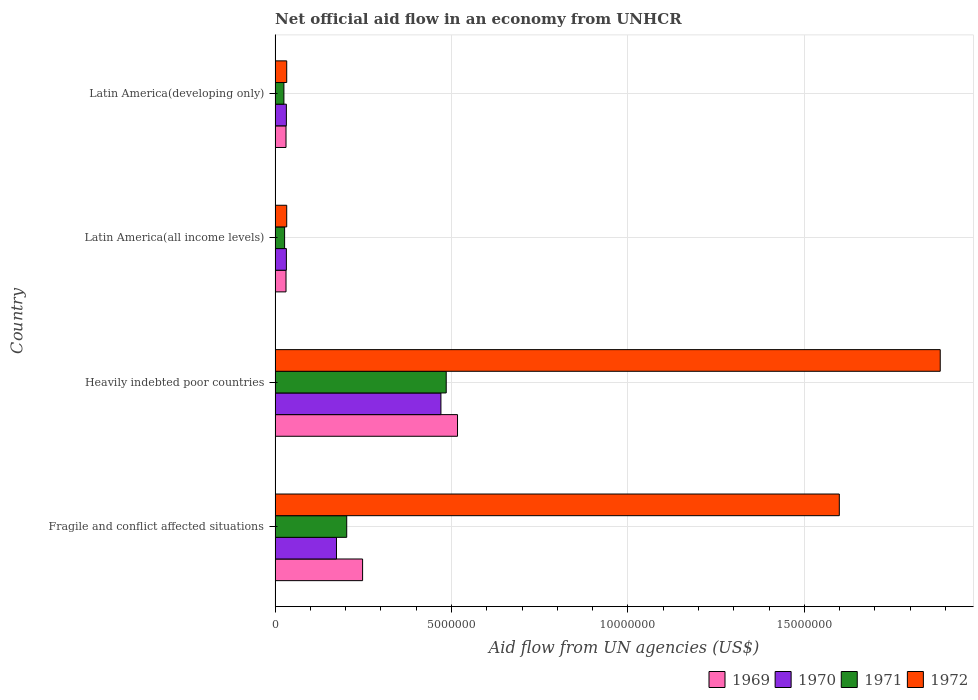How many groups of bars are there?
Your answer should be compact. 4. Are the number of bars per tick equal to the number of legend labels?
Ensure brevity in your answer.  Yes. Are the number of bars on each tick of the Y-axis equal?
Make the answer very short. Yes. How many bars are there on the 3rd tick from the top?
Ensure brevity in your answer.  4. How many bars are there on the 3rd tick from the bottom?
Give a very brief answer. 4. What is the label of the 1st group of bars from the top?
Your answer should be compact. Latin America(developing only). In how many cases, is the number of bars for a given country not equal to the number of legend labels?
Offer a terse response. 0. What is the net official aid flow in 1972 in Latin America(developing only)?
Give a very brief answer. 3.30e+05. Across all countries, what is the maximum net official aid flow in 1969?
Offer a terse response. 5.17e+06. Across all countries, what is the minimum net official aid flow in 1969?
Give a very brief answer. 3.10e+05. In which country was the net official aid flow in 1970 maximum?
Your response must be concise. Heavily indebted poor countries. In which country was the net official aid flow in 1969 minimum?
Ensure brevity in your answer.  Latin America(all income levels). What is the total net official aid flow in 1972 in the graph?
Your answer should be compact. 3.55e+07. What is the difference between the net official aid flow in 1969 in Heavily indebted poor countries and that in Latin America(developing only)?
Ensure brevity in your answer.  4.86e+06. What is the difference between the net official aid flow in 1971 in Heavily indebted poor countries and the net official aid flow in 1970 in Fragile and conflict affected situations?
Give a very brief answer. 3.11e+06. What is the average net official aid flow in 1970 per country?
Keep it short and to the point. 1.77e+06. In how many countries, is the net official aid flow in 1970 greater than 17000000 US$?
Provide a succinct answer. 0. What is the ratio of the net official aid flow in 1971 in Fragile and conflict affected situations to that in Latin America(developing only)?
Provide a succinct answer. 8.12. What is the difference between the highest and the second highest net official aid flow in 1969?
Your answer should be compact. 2.69e+06. What is the difference between the highest and the lowest net official aid flow in 1972?
Make the answer very short. 1.85e+07. What does the 1st bar from the bottom in Fragile and conflict affected situations represents?
Make the answer very short. 1969. How many countries are there in the graph?
Your response must be concise. 4. Does the graph contain any zero values?
Provide a short and direct response. No. Does the graph contain grids?
Provide a short and direct response. Yes. Where does the legend appear in the graph?
Your answer should be compact. Bottom right. What is the title of the graph?
Your response must be concise. Net official aid flow in an economy from UNHCR. Does "2005" appear as one of the legend labels in the graph?
Your response must be concise. No. What is the label or title of the X-axis?
Ensure brevity in your answer.  Aid flow from UN agencies (US$). What is the Aid flow from UN agencies (US$) in 1969 in Fragile and conflict affected situations?
Your response must be concise. 2.48e+06. What is the Aid flow from UN agencies (US$) of 1970 in Fragile and conflict affected situations?
Ensure brevity in your answer.  1.74e+06. What is the Aid flow from UN agencies (US$) in 1971 in Fragile and conflict affected situations?
Your response must be concise. 2.03e+06. What is the Aid flow from UN agencies (US$) of 1972 in Fragile and conflict affected situations?
Your response must be concise. 1.60e+07. What is the Aid flow from UN agencies (US$) in 1969 in Heavily indebted poor countries?
Your answer should be compact. 5.17e+06. What is the Aid flow from UN agencies (US$) in 1970 in Heavily indebted poor countries?
Provide a short and direct response. 4.70e+06. What is the Aid flow from UN agencies (US$) in 1971 in Heavily indebted poor countries?
Offer a terse response. 4.85e+06. What is the Aid flow from UN agencies (US$) of 1972 in Heavily indebted poor countries?
Offer a terse response. 1.88e+07. What is the Aid flow from UN agencies (US$) of 1969 in Latin America(all income levels)?
Your response must be concise. 3.10e+05. What is the Aid flow from UN agencies (US$) of 1971 in Latin America(all income levels)?
Your answer should be very brief. 2.70e+05. What is the Aid flow from UN agencies (US$) in 1971 in Latin America(developing only)?
Give a very brief answer. 2.50e+05. Across all countries, what is the maximum Aid flow from UN agencies (US$) in 1969?
Offer a very short reply. 5.17e+06. Across all countries, what is the maximum Aid flow from UN agencies (US$) in 1970?
Your response must be concise. 4.70e+06. Across all countries, what is the maximum Aid flow from UN agencies (US$) in 1971?
Offer a very short reply. 4.85e+06. Across all countries, what is the maximum Aid flow from UN agencies (US$) of 1972?
Keep it short and to the point. 1.88e+07. Across all countries, what is the minimum Aid flow from UN agencies (US$) of 1971?
Give a very brief answer. 2.50e+05. Across all countries, what is the minimum Aid flow from UN agencies (US$) in 1972?
Offer a very short reply. 3.30e+05. What is the total Aid flow from UN agencies (US$) of 1969 in the graph?
Offer a terse response. 8.27e+06. What is the total Aid flow from UN agencies (US$) in 1970 in the graph?
Give a very brief answer. 7.08e+06. What is the total Aid flow from UN agencies (US$) in 1971 in the graph?
Give a very brief answer. 7.40e+06. What is the total Aid flow from UN agencies (US$) of 1972 in the graph?
Your answer should be very brief. 3.55e+07. What is the difference between the Aid flow from UN agencies (US$) in 1969 in Fragile and conflict affected situations and that in Heavily indebted poor countries?
Your response must be concise. -2.69e+06. What is the difference between the Aid flow from UN agencies (US$) of 1970 in Fragile and conflict affected situations and that in Heavily indebted poor countries?
Keep it short and to the point. -2.96e+06. What is the difference between the Aid flow from UN agencies (US$) of 1971 in Fragile and conflict affected situations and that in Heavily indebted poor countries?
Your answer should be very brief. -2.82e+06. What is the difference between the Aid flow from UN agencies (US$) in 1972 in Fragile and conflict affected situations and that in Heavily indebted poor countries?
Offer a very short reply. -2.86e+06. What is the difference between the Aid flow from UN agencies (US$) in 1969 in Fragile and conflict affected situations and that in Latin America(all income levels)?
Offer a very short reply. 2.17e+06. What is the difference between the Aid flow from UN agencies (US$) in 1970 in Fragile and conflict affected situations and that in Latin America(all income levels)?
Ensure brevity in your answer.  1.42e+06. What is the difference between the Aid flow from UN agencies (US$) of 1971 in Fragile and conflict affected situations and that in Latin America(all income levels)?
Provide a succinct answer. 1.76e+06. What is the difference between the Aid flow from UN agencies (US$) in 1972 in Fragile and conflict affected situations and that in Latin America(all income levels)?
Offer a terse response. 1.57e+07. What is the difference between the Aid flow from UN agencies (US$) in 1969 in Fragile and conflict affected situations and that in Latin America(developing only)?
Offer a terse response. 2.17e+06. What is the difference between the Aid flow from UN agencies (US$) of 1970 in Fragile and conflict affected situations and that in Latin America(developing only)?
Your answer should be very brief. 1.42e+06. What is the difference between the Aid flow from UN agencies (US$) of 1971 in Fragile and conflict affected situations and that in Latin America(developing only)?
Your answer should be very brief. 1.78e+06. What is the difference between the Aid flow from UN agencies (US$) of 1972 in Fragile and conflict affected situations and that in Latin America(developing only)?
Your answer should be very brief. 1.57e+07. What is the difference between the Aid flow from UN agencies (US$) of 1969 in Heavily indebted poor countries and that in Latin America(all income levels)?
Give a very brief answer. 4.86e+06. What is the difference between the Aid flow from UN agencies (US$) in 1970 in Heavily indebted poor countries and that in Latin America(all income levels)?
Offer a very short reply. 4.38e+06. What is the difference between the Aid flow from UN agencies (US$) in 1971 in Heavily indebted poor countries and that in Latin America(all income levels)?
Offer a very short reply. 4.58e+06. What is the difference between the Aid flow from UN agencies (US$) in 1972 in Heavily indebted poor countries and that in Latin America(all income levels)?
Your answer should be compact. 1.85e+07. What is the difference between the Aid flow from UN agencies (US$) in 1969 in Heavily indebted poor countries and that in Latin America(developing only)?
Offer a very short reply. 4.86e+06. What is the difference between the Aid flow from UN agencies (US$) of 1970 in Heavily indebted poor countries and that in Latin America(developing only)?
Offer a very short reply. 4.38e+06. What is the difference between the Aid flow from UN agencies (US$) of 1971 in Heavily indebted poor countries and that in Latin America(developing only)?
Provide a succinct answer. 4.60e+06. What is the difference between the Aid flow from UN agencies (US$) of 1972 in Heavily indebted poor countries and that in Latin America(developing only)?
Your answer should be very brief. 1.85e+07. What is the difference between the Aid flow from UN agencies (US$) in 1969 in Latin America(all income levels) and that in Latin America(developing only)?
Your answer should be very brief. 0. What is the difference between the Aid flow from UN agencies (US$) in 1970 in Latin America(all income levels) and that in Latin America(developing only)?
Keep it short and to the point. 0. What is the difference between the Aid flow from UN agencies (US$) of 1972 in Latin America(all income levels) and that in Latin America(developing only)?
Keep it short and to the point. 0. What is the difference between the Aid flow from UN agencies (US$) of 1969 in Fragile and conflict affected situations and the Aid flow from UN agencies (US$) of 1970 in Heavily indebted poor countries?
Provide a short and direct response. -2.22e+06. What is the difference between the Aid flow from UN agencies (US$) of 1969 in Fragile and conflict affected situations and the Aid flow from UN agencies (US$) of 1971 in Heavily indebted poor countries?
Keep it short and to the point. -2.37e+06. What is the difference between the Aid flow from UN agencies (US$) of 1969 in Fragile and conflict affected situations and the Aid flow from UN agencies (US$) of 1972 in Heavily indebted poor countries?
Keep it short and to the point. -1.64e+07. What is the difference between the Aid flow from UN agencies (US$) in 1970 in Fragile and conflict affected situations and the Aid flow from UN agencies (US$) in 1971 in Heavily indebted poor countries?
Offer a very short reply. -3.11e+06. What is the difference between the Aid flow from UN agencies (US$) in 1970 in Fragile and conflict affected situations and the Aid flow from UN agencies (US$) in 1972 in Heavily indebted poor countries?
Keep it short and to the point. -1.71e+07. What is the difference between the Aid flow from UN agencies (US$) in 1971 in Fragile and conflict affected situations and the Aid flow from UN agencies (US$) in 1972 in Heavily indebted poor countries?
Keep it short and to the point. -1.68e+07. What is the difference between the Aid flow from UN agencies (US$) of 1969 in Fragile and conflict affected situations and the Aid flow from UN agencies (US$) of 1970 in Latin America(all income levels)?
Ensure brevity in your answer.  2.16e+06. What is the difference between the Aid flow from UN agencies (US$) in 1969 in Fragile and conflict affected situations and the Aid flow from UN agencies (US$) in 1971 in Latin America(all income levels)?
Your response must be concise. 2.21e+06. What is the difference between the Aid flow from UN agencies (US$) in 1969 in Fragile and conflict affected situations and the Aid flow from UN agencies (US$) in 1972 in Latin America(all income levels)?
Offer a terse response. 2.15e+06. What is the difference between the Aid flow from UN agencies (US$) of 1970 in Fragile and conflict affected situations and the Aid flow from UN agencies (US$) of 1971 in Latin America(all income levels)?
Your answer should be compact. 1.47e+06. What is the difference between the Aid flow from UN agencies (US$) in 1970 in Fragile and conflict affected situations and the Aid flow from UN agencies (US$) in 1972 in Latin America(all income levels)?
Give a very brief answer. 1.41e+06. What is the difference between the Aid flow from UN agencies (US$) of 1971 in Fragile and conflict affected situations and the Aid flow from UN agencies (US$) of 1972 in Latin America(all income levels)?
Your response must be concise. 1.70e+06. What is the difference between the Aid flow from UN agencies (US$) of 1969 in Fragile and conflict affected situations and the Aid flow from UN agencies (US$) of 1970 in Latin America(developing only)?
Offer a very short reply. 2.16e+06. What is the difference between the Aid flow from UN agencies (US$) of 1969 in Fragile and conflict affected situations and the Aid flow from UN agencies (US$) of 1971 in Latin America(developing only)?
Offer a very short reply. 2.23e+06. What is the difference between the Aid flow from UN agencies (US$) of 1969 in Fragile and conflict affected situations and the Aid flow from UN agencies (US$) of 1972 in Latin America(developing only)?
Provide a short and direct response. 2.15e+06. What is the difference between the Aid flow from UN agencies (US$) of 1970 in Fragile and conflict affected situations and the Aid flow from UN agencies (US$) of 1971 in Latin America(developing only)?
Your answer should be very brief. 1.49e+06. What is the difference between the Aid flow from UN agencies (US$) of 1970 in Fragile and conflict affected situations and the Aid flow from UN agencies (US$) of 1972 in Latin America(developing only)?
Make the answer very short. 1.41e+06. What is the difference between the Aid flow from UN agencies (US$) of 1971 in Fragile and conflict affected situations and the Aid flow from UN agencies (US$) of 1972 in Latin America(developing only)?
Your answer should be very brief. 1.70e+06. What is the difference between the Aid flow from UN agencies (US$) of 1969 in Heavily indebted poor countries and the Aid flow from UN agencies (US$) of 1970 in Latin America(all income levels)?
Offer a terse response. 4.85e+06. What is the difference between the Aid flow from UN agencies (US$) of 1969 in Heavily indebted poor countries and the Aid flow from UN agencies (US$) of 1971 in Latin America(all income levels)?
Provide a succinct answer. 4.90e+06. What is the difference between the Aid flow from UN agencies (US$) in 1969 in Heavily indebted poor countries and the Aid flow from UN agencies (US$) in 1972 in Latin America(all income levels)?
Provide a short and direct response. 4.84e+06. What is the difference between the Aid flow from UN agencies (US$) in 1970 in Heavily indebted poor countries and the Aid flow from UN agencies (US$) in 1971 in Latin America(all income levels)?
Your answer should be compact. 4.43e+06. What is the difference between the Aid flow from UN agencies (US$) in 1970 in Heavily indebted poor countries and the Aid flow from UN agencies (US$) in 1972 in Latin America(all income levels)?
Provide a succinct answer. 4.37e+06. What is the difference between the Aid flow from UN agencies (US$) in 1971 in Heavily indebted poor countries and the Aid flow from UN agencies (US$) in 1972 in Latin America(all income levels)?
Provide a succinct answer. 4.52e+06. What is the difference between the Aid flow from UN agencies (US$) of 1969 in Heavily indebted poor countries and the Aid flow from UN agencies (US$) of 1970 in Latin America(developing only)?
Your response must be concise. 4.85e+06. What is the difference between the Aid flow from UN agencies (US$) of 1969 in Heavily indebted poor countries and the Aid flow from UN agencies (US$) of 1971 in Latin America(developing only)?
Provide a short and direct response. 4.92e+06. What is the difference between the Aid flow from UN agencies (US$) in 1969 in Heavily indebted poor countries and the Aid flow from UN agencies (US$) in 1972 in Latin America(developing only)?
Provide a succinct answer. 4.84e+06. What is the difference between the Aid flow from UN agencies (US$) in 1970 in Heavily indebted poor countries and the Aid flow from UN agencies (US$) in 1971 in Latin America(developing only)?
Provide a short and direct response. 4.45e+06. What is the difference between the Aid flow from UN agencies (US$) of 1970 in Heavily indebted poor countries and the Aid flow from UN agencies (US$) of 1972 in Latin America(developing only)?
Your answer should be compact. 4.37e+06. What is the difference between the Aid flow from UN agencies (US$) in 1971 in Heavily indebted poor countries and the Aid flow from UN agencies (US$) in 1972 in Latin America(developing only)?
Give a very brief answer. 4.52e+06. What is the difference between the Aid flow from UN agencies (US$) in 1969 in Latin America(all income levels) and the Aid flow from UN agencies (US$) in 1971 in Latin America(developing only)?
Your answer should be very brief. 6.00e+04. What is the difference between the Aid flow from UN agencies (US$) of 1969 in Latin America(all income levels) and the Aid flow from UN agencies (US$) of 1972 in Latin America(developing only)?
Your answer should be compact. -2.00e+04. What is the difference between the Aid flow from UN agencies (US$) of 1970 in Latin America(all income levels) and the Aid flow from UN agencies (US$) of 1971 in Latin America(developing only)?
Keep it short and to the point. 7.00e+04. What is the average Aid flow from UN agencies (US$) of 1969 per country?
Provide a short and direct response. 2.07e+06. What is the average Aid flow from UN agencies (US$) in 1970 per country?
Your answer should be very brief. 1.77e+06. What is the average Aid flow from UN agencies (US$) in 1971 per country?
Your answer should be very brief. 1.85e+06. What is the average Aid flow from UN agencies (US$) in 1972 per country?
Make the answer very short. 8.88e+06. What is the difference between the Aid flow from UN agencies (US$) in 1969 and Aid flow from UN agencies (US$) in 1970 in Fragile and conflict affected situations?
Ensure brevity in your answer.  7.40e+05. What is the difference between the Aid flow from UN agencies (US$) in 1969 and Aid flow from UN agencies (US$) in 1971 in Fragile and conflict affected situations?
Your answer should be very brief. 4.50e+05. What is the difference between the Aid flow from UN agencies (US$) in 1969 and Aid flow from UN agencies (US$) in 1972 in Fragile and conflict affected situations?
Provide a short and direct response. -1.35e+07. What is the difference between the Aid flow from UN agencies (US$) in 1970 and Aid flow from UN agencies (US$) in 1971 in Fragile and conflict affected situations?
Make the answer very short. -2.90e+05. What is the difference between the Aid flow from UN agencies (US$) of 1970 and Aid flow from UN agencies (US$) of 1972 in Fragile and conflict affected situations?
Provide a succinct answer. -1.42e+07. What is the difference between the Aid flow from UN agencies (US$) of 1971 and Aid flow from UN agencies (US$) of 1972 in Fragile and conflict affected situations?
Offer a terse response. -1.40e+07. What is the difference between the Aid flow from UN agencies (US$) of 1969 and Aid flow from UN agencies (US$) of 1970 in Heavily indebted poor countries?
Provide a short and direct response. 4.70e+05. What is the difference between the Aid flow from UN agencies (US$) in 1969 and Aid flow from UN agencies (US$) in 1972 in Heavily indebted poor countries?
Your answer should be very brief. -1.37e+07. What is the difference between the Aid flow from UN agencies (US$) in 1970 and Aid flow from UN agencies (US$) in 1971 in Heavily indebted poor countries?
Provide a short and direct response. -1.50e+05. What is the difference between the Aid flow from UN agencies (US$) of 1970 and Aid flow from UN agencies (US$) of 1972 in Heavily indebted poor countries?
Your answer should be compact. -1.42e+07. What is the difference between the Aid flow from UN agencies (US$) of 1971 and Aid flow from UN agencies (US$) of 1972 in Heavily indebted poor countries?
Your answer should be compact. -1.40e+07. What is the difference between the Aid flow from UN agencies (US$) in 1969 and Aid flow from UN agencies (US$) in 1970 in Latin America(all income levels)?
Give a very brief answer. -10000. What is the difference between the Aid flow from UN agencies (US$) in 1969 and Aid flow from UN agencies (US$) in 1972 in Latin America(all income levels)?
Offer a very short reply. -2.00e+04. What is the difference between the Aid flow from UN agencies (US$) of 1970 and Aid flow from UN agencies (US$) of 1972 in Latin America(all income levels)?
Your response must be concise. -10000. What is the difference between the Aid flow from UN agencies (US$) in 1971 and Aid flow from UN agencies (US$) in 1972 in Latin America(all income levels)?
Your answer should be compact. -6.00e+04. What is the difference between the Aid flow from UN agencies (US$) of 1970 and Aid flow from UN agencies (US$) of 1971 in Latin America(developing only)?
Provide a short and direct response. 7.00e+04. What is the difference between the Aid flow from UN agencies (US$) in 1970 and Aid flow from UN agencies (US$) in 1972 in Latin America(developing only)?
Keep it short and to the point. -10000. What is the ratio of the Aid flow from UN agencies (US$) of 1969 in Fragile and conflict affected situations to that in Heavily indebted poor countries?
Your answer should be very brief. 0.48. What is the ratio of the Aid flow from UN agencies (US$) in 1970 in Fragile and conflict affected situations to that in Heavily indebted poor countries?
Ensure brevity in your answer.  0.37. What is the ratio of the Aid flow from UN agencies (US$) of 1971 in Fragile and conflict affected situations to that in Heavily indebted poor countries?
Your answer should be compact. 0.42. What is the ratio of the Aid flow from UN agencies (US$) in 1972 in Fragile and conflict affected situations to that in Heavily indebted poor countries?
Keep it short and to the point. 0.85. What is the ratio of the Aid flow from UN agencies (US$) in 1969 in Fragile and conflict affected situations to that in Latin America(all income levels)?
Your response must be concise. 8. What is the ratio of the Aid flow from UN agencies (US$) of 1970 in Fragile and conflict affected situations to that in Latin America(all income levels)?
Your response must be concise. 5.44. What is the ratio of the Aid flow from UN agencies (US$) of 1971 in Fragile and conflict affected situations to that in Latin America(all income levels)?
Make the answer very short. 7.52. What is the ratio of the Aid flow from UN agencies (US$) in 1972 in Fragile and conflict affected situations to that in Latin America(all income levels)?
Ensure brevity in your answer.  48.45. What is the ratio of the Aid flow from UN agencies (US$) of 1970 in Fragile and conflict affected situations to that in Latin America(developing only)?
Provide a succinct answer. 5.44. What is the ratio of the Aid flow from UN agencies (US$) of 1971 in Fragile and conflict affected situations to that in Latin America(developing only)?
Your answer should be very brief. 8.12. What is the ratio of the Aid flow from UN agencies (US$) of 1972 in Fragile and conflict affected situations to that in Latin America(developing only)?
Offer a very short reply. 48.45. What is the ratio of the Aid flow from UN agencies (US$) of 1969 in Heavily indebted poor countries to that in Latin America(all income levels)?
Offer a terse response. 16.68. What is the ratio of the Aid flow from UN agencies (US$) of 1970 in Heavily indebted poor countries to that in Latin America(all income levels)?
Your answer should be very brief. 14.69. What is the ratio of the Aid flow from UN agencies (US$) of 1971 in Heavily indebted poor countries to that in Latin America(all income levels)?
Your answer should be compact. 17.96. What is the ratio of the Aid flow from UN agencies (US$) of 1972 in Heavily indebted poor countries to that in Latin America(all income levels)?
Your answer should be compact. 57.12. What is the ratio of the Aid flow from UN agencies (US$) of 1969 in Heavily indebted poor countries to that in Latin America(developing only)?
Your answer should be very brief. 16.68. What is the ratio of the Aid flow from UN agencies (US$) in 1970 in Heavily indebted poor countries to that in Latin America(developing only)?
Your response must be concise. 14.69. What is the ratio of the Aid flow from UN agencies (US$) in 1971 in Heavily indebted poor countries to that in Latin America(developing only)?
Ensure brevity in your answer.  19.4. What is the ratio of the Aid flow from UN agencies (US$) in 1972 in Heavily indebted poor countries to that in Latin America(developing only)?
Keep it short and to the point. 57.12. What is the difference between the highest and the second highest Aid flow from UN agencies (US$) of 1969?
Offer a terse response. 2.69e+06. What is the difference between the highest and the second highest Aid flow from UN agencies (US$) in 1970?
Give a very brief answer. 2.96e+06. What is the difference between the highest and the second highest Aid flow from UN agencies (US$) of 1971?
Offer a terse response. 2.82e+06. What is the difference between the highest and the second highest Aid flow from UN agencies (US$) in 1972?
Your answer should be very brief. 2.86e+06. What is the difference between the highest and the lowest Aid flow from UN agencies (US$) in 1969?
Provide a short and direct response. 4.86e+06. What is the difference between the highest and the lowest Aid flow from UN agencies (US$) in 1970?
Ensure brevity in your answer.  4.38e+06. What is the difference between the highest and the lowest Aid flow from UN agencies (US$) in 1971?
Your response must be concise. 4.60e+06. What is the difference between the highest and the lowest Aid flow from UN agencies (US$) of 1972?
Your response must be concise. 1.85e+07. 